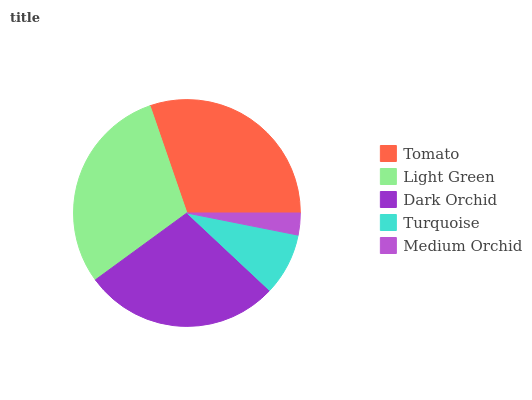Is Medium Orchid the minimum?
Answer yes or no. Yes. Is Tomato the maximum?
Answer yes or no. Yes. Is Light Green the minimum?
Answer yes or no. No. Is Light Green the maximum?
Answer yes or no. No. Is Tomato greater than Light Green?
Answer yes or no. Yes. Is Light Green less than Tomato?
Answer yes or no. Yes. Is Light Green greater than Tomato?
Answer yes or no. No. Is Tomato less than Light Green?
Answer yes or no. No. Is Dark Orchid the high median?
Answer yes or no. Yes. Is Dark Orchid the low median?
Answer yes or no. Yes. Is Tomato the high median?
Answer yes or no. No. Is Tomato the low median?
Answer yes or no. No. 